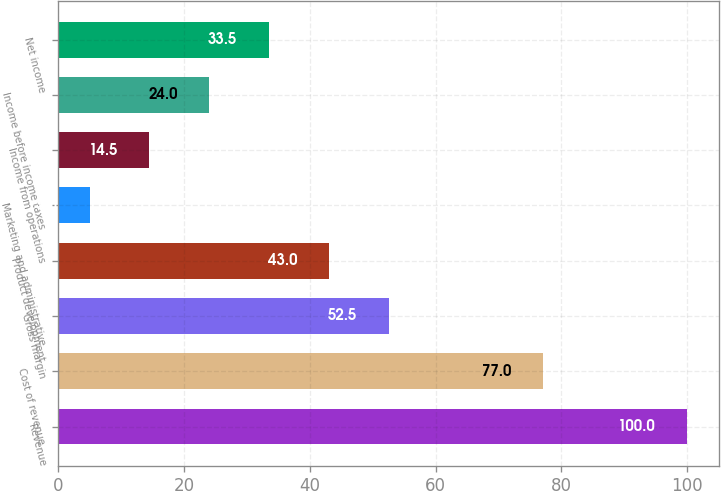Convert chart to OTSL. <chart><loc_0><loc_0><loc_500><loc_500><bar_chart><fcel>Revenue<fcel>Cost of revenue<fcel>Gross margin<fcel>Product development<fcel>Marketing and administrative<fcel>Income from operations<fcel>Income before income taxes<fcel>Net income<nl><fcel>100<fcel>77<fcel>52.5<fcel>43<fcel>5<fcel>14.5<fcel>24<fcel>33.5<nl></chart> 